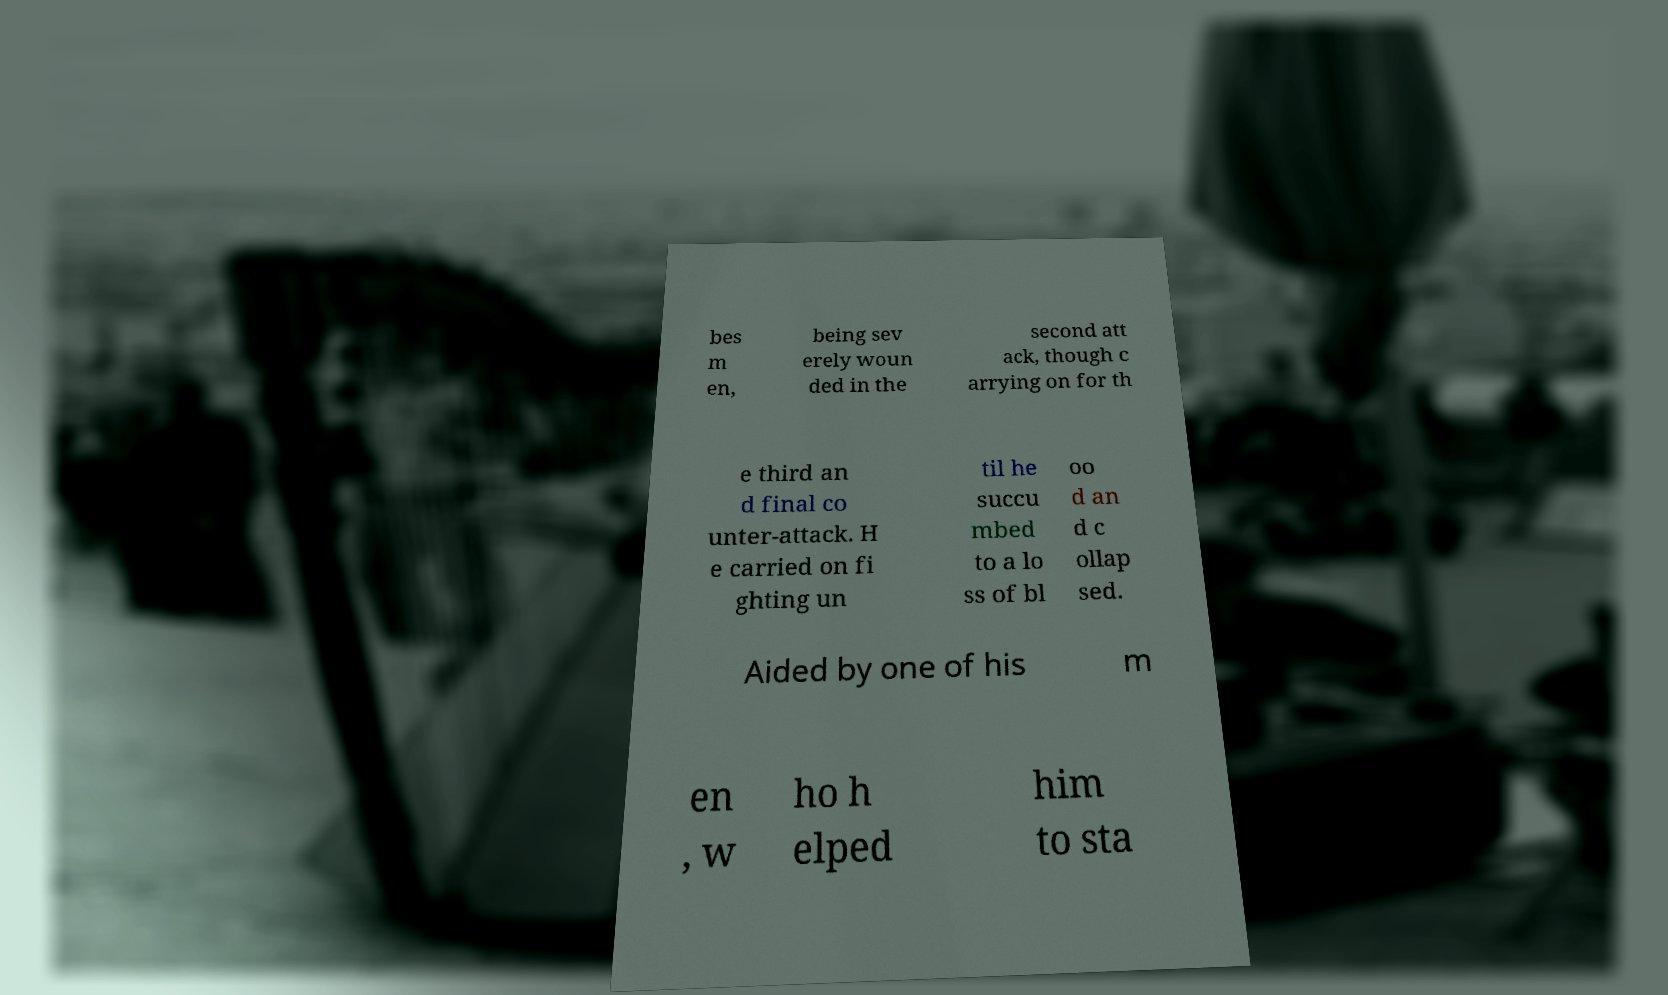Please read and relay the text visible in this image. What does it say? bes m en, being sev erely woun ded in the second att ack, though c arrying on for th e third an d final co unter-attack. H e carried on fi ghting un til he succu mbed to a lo ss of bl oo d an d c ollap sed. Aided by one of his m en , w ho h elped him to sta 